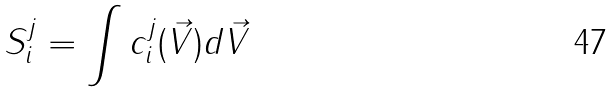<formula> <loc_0><loc_0><loc_500><loc_500>S _ { i } ^ { j } = \int c _ { i } ^ { j } ( \vec { V } ) d \vec { V }</formula> 